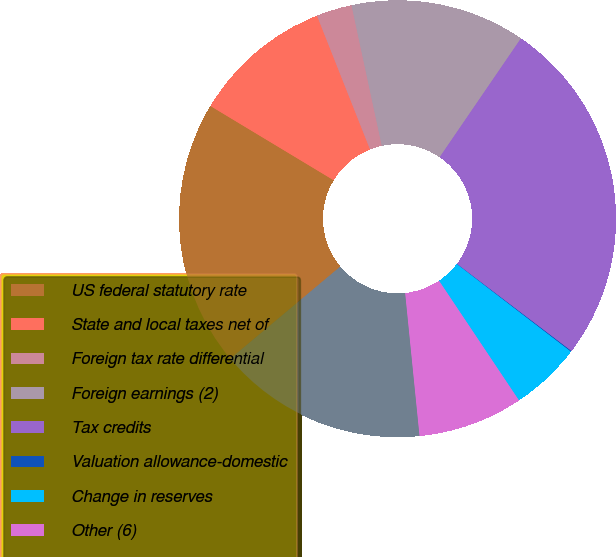<chart> <loc_0><loc_0><loc_500><loc_500><pie_chart><fcel>US federal statutory rate<fcel>State and local taxes net of<fcel>Foreign tax rate differential<fcel>Foreign earnings (2)<fcel>Tax credits<fcel>Valuation allowance-domestic<fcel>Change in reserves<fcel>Other (6)<fcel>Effective tax rate<nl><fcel>19.72%<fcel>10.36%<fcel>2.63%<fcel>12.93%<fcel>25.81%<fcel>0.06%<fcel>5.21%<fcel>7.78%<fcel>15.51%<nl></chart> 